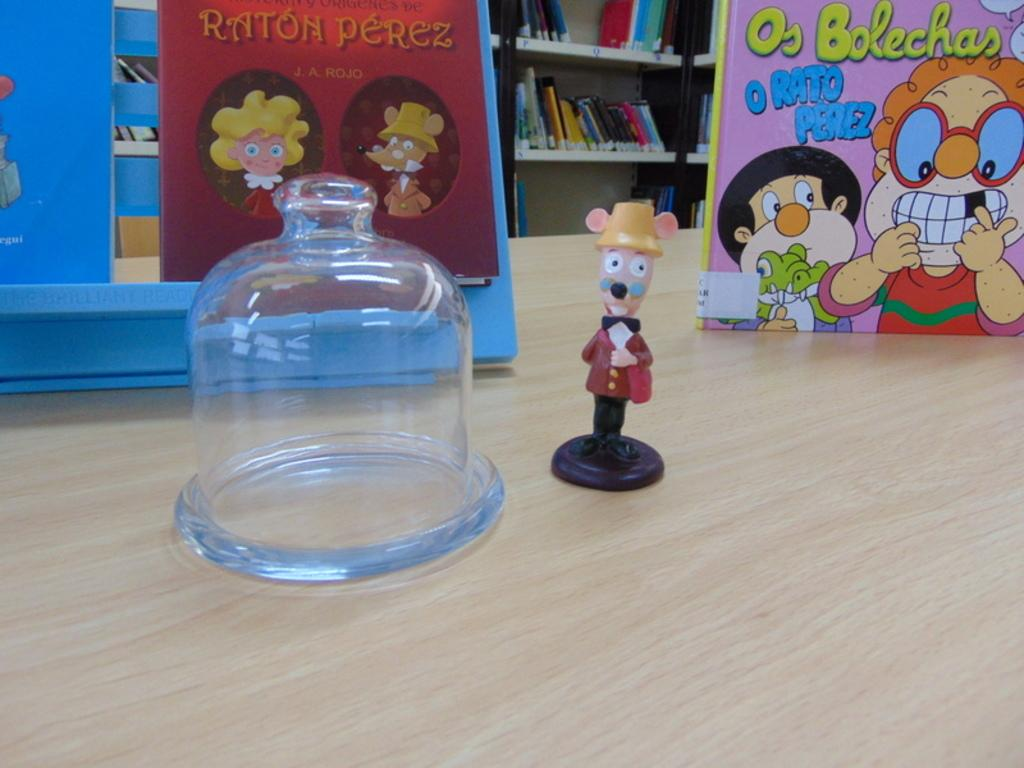<image>
Summarize the visual content of the image. The library has two children's books in Spanish displayed, both written by Raton Perez. 